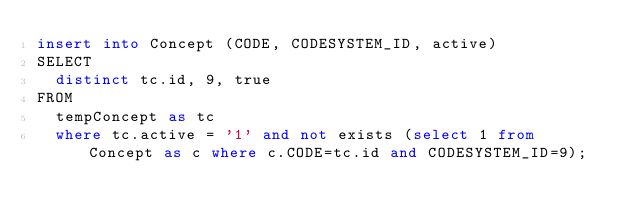Convert code to text. <code><loc_0><loc_0><loc_500><loc_500><_SQL_>insert into Concept (CODE, CODESYSTEM_ID, active)
SELECT
	distinct tc.id, 9, true
FROM
	tempConcept as tc
	where tc.active = '1' and not exists (select 1 from Concept as c where c.CODE=tc.id and CODESYSTEM_ID=9);</code> 